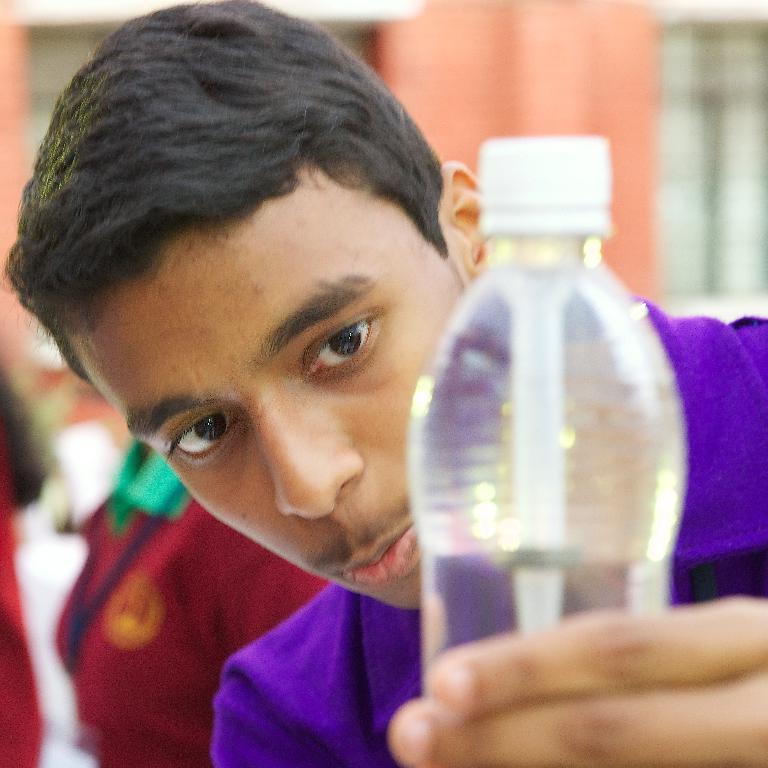Please provide a concise description of this image. In this picture there is a boy, holding a water bottle in his left hand and he is looking at the water bottle and in the background as some people and there is a building 